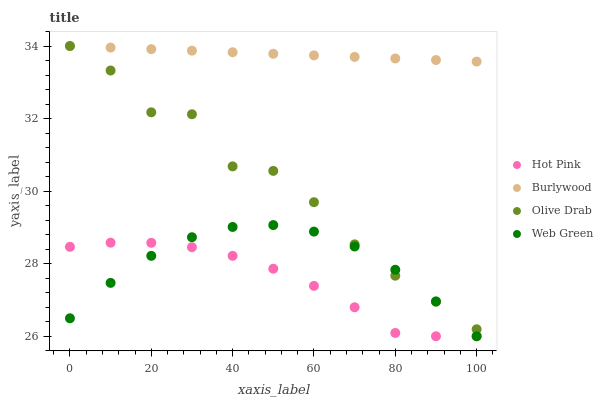Does Hot Pink have the minimum area under the curve?
Answer yes or no. Yes. Does Burlywood have the maximum area under the curve?
Answer yes or no. Yes. Does Web Green have the minimum area under the curve?
Answer yes or no. No. Does Web Green have the maximum area under the curve?
Answer yes or no. No. Is Burlywood the smoothest?
Answer yes or no. Yes. Is Olive Drab the roughest?
Answer yes or no. Yes. Is Hot Pink the smoothest?
Answer yes or no. No. Is Hot Pink the roughest?
Answer yes or no. No. Does Hot Pink have the lowest value?
Answer yes or no. Yes. Does Olive Drab have the lowest value?
Answer yes or no. No. Does Olive Drab have the highest value?
Answer yes or no. Yes. Does Web Green have the highest value?
Answer yes or no. No. Is Web Green less than Burlywood?
Answer yes or no. Yes. Is Burlywood greater than Web Green?
Answer yes or no. Yes. Does Web Green intersect Olive Drab?
Answer yes or no. Yes. Is Web Green less than Olive Drab?
Answer yes or no. No. Is Web Green greater than Olive Drab?
Answer yes or no. No. Does Web Green intersect Burlywood?
Answer yes or no. No. 